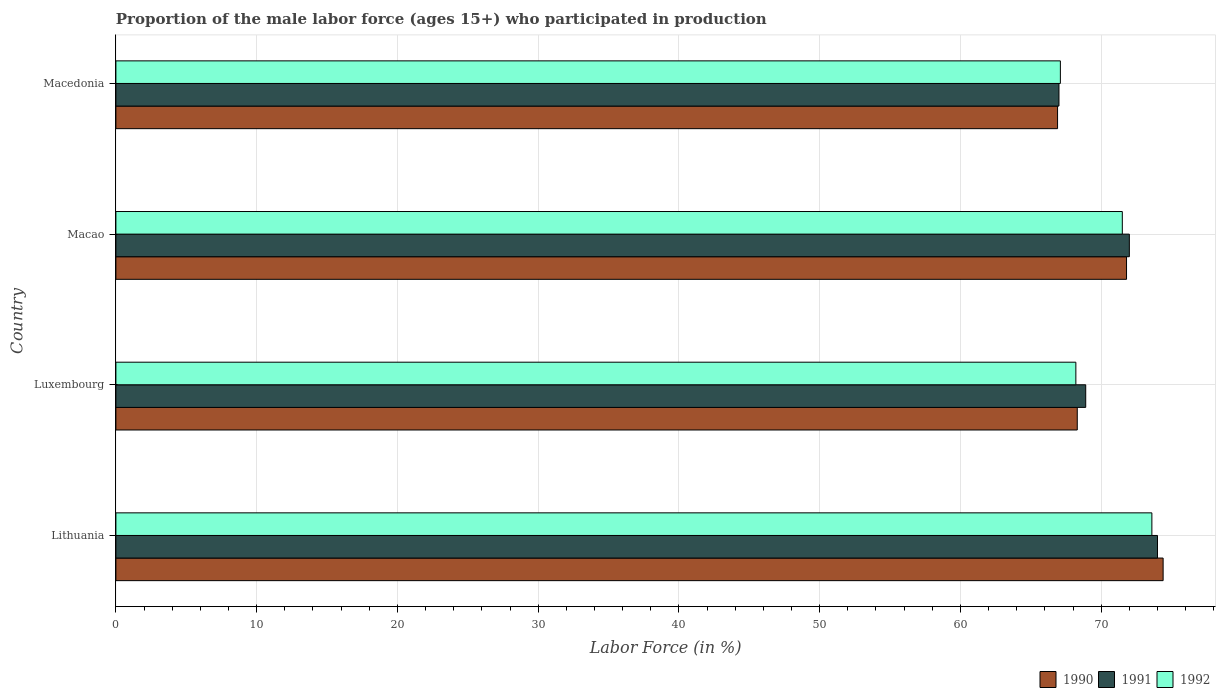How many groups of bars are there?
Your response must be concise. 4. Are the number of bars per tick equal to the number of legend labels?
Provide a short and direct response. Yes. Are the number of bars on each tick of the Y-axis equal?
Your response must be concise. Yes. How many bars are there on the 2nd tick from the bottom?
Your response must be concise. 3. What is the label of the 4th group of bars from the top?
Your answer should be very brief. Lithuania. What is the proportion of the male labor force who participated in production in 1990 in Macao?
Keep it short and to the point. 71.8. Across all countries, what is the maximum proportion of the male labor force who participated in production in 1990?
Your response must be concise. 74.4. Across all countries, what is the minimum proportion of the male labor force who participated in production in 1991?
Give a very brief answer. 67. In which country was the proportion of the male labor force who participated in production in 1991 maximum?
Your answer should be compact. Lithuania. In which country was the proportion of the male labor force who participated in production in 1992 minimum?
Offer a terse response. Macedonia. What is the total proportion of the male labor force who participated in production in 1992 in the graph?
Provide a succinct answer. 280.4. What is the difference between the proportion of the male labor force who participated in production in 1992 in Lithuania and that in Macao?
Keep it short and to the point. 2.1. What is the difference between the proportion of the male labor force who participated in production in 1992 in Macao and the proportion of the male labor force who participated in production in 1991 in Luxembourg?
Ensure brevity in your answer.  2.6. What is the average proportion of the male labor force who participated in production in 1990 per country?
Provide a short and direct response. 70.35. What is the difference between the proportion of the male labor force who participated in production in 1992 and proportion of the male labor force who participated in production in 1991 in Luxembourg?
Your answer should be very brief. -0.7. What is the ratio of the proportion of the male labor force who participated in production in 1991 in Lithuania to that in Luxembourg?
Your answer should be compact. 1.07. Is the difference between the proportion of the male labor force who participated in production in 1992 in Lithuania and Luxembourg greater than the difference between the proportion of the male labor force who participated in production in 1991 in Lithuania and Luxembourg?
Make the answer very short. Yes. What is the difference between the highest and the second highest proportion of the male labor force who participated in production in 1990?
Give a very brief answer. 2.6. Is it the case that in every country, the sum of the proportion of the male labor force who participated in production in 1991 and proportion of the male labor force who participated in production in 1990 is greater than the proportion of the male labor force who participated in production in 1992?
Offer a very short reply. Yes. How many bars are there?
Make the answer very short. 12. Are the values on the major ticks of X-axis written in scientific E-notation?
Ensure brevity in your answer.  No. Does the graph contain any zero values?
Your answer should be compact. No. Does the graph contain grids?
Provide a succinct answer. Yes. What is the title of the graph?
Offer a terse response. Proportion of the male labor force (ages 15+) who participated in production. Does "2013" appear as one of the legend labels in the graph?
Offer a very short reply. No. What is the label or title of the X-axis?
Provide a short and direct response. Labor Force (in %). What is the Labor Force (in %) of 1990 in Lithuania?
Make the answer very short. 74.4. What is the Labor Force (in %) in 1991 in Lithuania?
Keep it short and to the point. 74. What is the Labor Force (in %) of 1992 in Lithuania?
Offer a terse response. 73.6. What is the Labor Force (in %) of 1990 in Luxembourg?
Keep it short and to the point. 68.3. What is the Labor Force (in %) of 1991 in Luxembourg?
Your answer should be compact. 68.9. What is the Labor Force (in %) in 1992 in Luxembourg?
Offer a terse response. 68.2. What is the Labor Force (in %) in 1990 in Macao?
Provide a short and direct response. 71.8. What is the Labor Force (in %) in 1992 in Macao?
Provide a short and direct response. 71.5. What is the Labor Force (in %) of 1990 in Macedonia?
Ensure brevity in your answer.  66.9. What is the Labor Force (in %) in 1991 in Macedonia?
Your response must be concise. 67. What is the Labor Force (in %) in 1992 in Macedonia?
Your response must be concise. 67.1. Across all countries, what is the maximum Labor Force (in %) of 1990?
Offer a terse response. 74.4. Across all countries, what is the maximum Labor Force (in %) of 1992?
Offer a very short reply. 73.6. Across all countries, what is the minimum Labor Force (in %) of 1990?
Provide a short and direct response. 66.9. Across all countries, what is the minimum Labor Force (in %) in 1992?
Offer a terse response. 67.1. What is the total Labor Force (in %) of 1990 in the graph?
Ensure brevity in your answer.  281.4. What is the total Labor Force (in %) of 1991 in the graph?
Offer a terse response. 281.9. What is the total Labor Force (in %) in 1992 in the graph?
Your response must be concise. 280.4. What is the difference between the Labor Force (in %) of 1991 in Lithuania and that in Luxembourg?
Offer a very short reply. 5.1. What is the difference between the Labor Force (in %) in 1990 in Lithuania and that in Macedonia?
Your answer should be compact. 7.5. What is the difference between the Labor Force (in %) of 1990 in Luxembourg and that in Macao?
Keep it short and to the point. -3.5. What is the difference between the Labor Force (in %) of 1990 in Luxembourg and that in Macedonia?
Make the answer very short. 1.4. What is the difference between the Labor Force (in %) in 1992 in Luxembourg and that in Macedonia?
Make the answer very short. 1.1. What is the difference between the Labor Force (in %) in 1991 in Macao and that in Macedonia?
Give a very brief answer. 5. What is the difference between the Labor Force (in %) of 1990 in Lithuania and the Labor Force (in %) of 1991 in Luxembourg?
Provide a succinct answer. 5.5. What is the difference between the Labor Force (in %) in 1991 in Lithuania and the Labor Force (in %) in 1992 in Luxembourg?
Ensure brevity in your answer.  5.8. What is the difference between the Labor Force (in %) in 1990 in Lithuania and the Labor Force (in %) in 1992 in Macao?
Provide a short and direct response. 2.9. What is the difference between the Labor Force (in %) of 1990 in Lithuania and the Labor Force (in %) of 1991 in Macedonia?
Make the answer very short. 7.4. What is the difference between the Labor Force (in %) of 1990 in Luxembourg and the Labor Force (in %) of 1991 in Macao?
Keep it short and to the point. -3.7. What is the difference between the Labor Force (in %) in 1991 in Luxembourg and the Labor Force (in %) in 1992 in Macedonia?
Make the answer very short. 1.8. What is the average Labor Force (in %) of 1990 per country?
Ensure brevity in your answer.  70.35. What is the average Labor Force (in %) of 1991 per country?
Offer a terse response. 70.47. What is the average Labor Force (in %) of 1992 per country?
Keep it short and to the point. 70.1. What is the difference between the Labor Force (in %) of 1990 and Labor Force (in %) of 1991 in Lithuania?
Your answer should be very brief. 0.4. What is the difference between the Labor Force (in %) of 1990 and Labor Force (in %) of 1992 in Lithuania?
Your answer should be compact. 0.8. What is the difference between the Labor Force (in %) of 1991 and Labor Force (in %) of 1992 in Lithuania?
Offer a terse response. 0.4. What is the difference between the Labor Force (in %) of 1990 and Labor Force (in %) of 1992 in Luxembourg?
Offer a terse response. 0.1. What is the difference between the Labor Force (in %) in 1990 and Labor Force (in %) in 1991 in Macao?
Offer a terse response. -0.2. What is the difference between the Labor Force (in %) in 1990 and Labor Force (in %) in 1992 in Macedonia?
Offer a very short reply. -0.2. What is the difference between the Labor Force (in %) of 1991 and Labor Force (in %) of 1992 in Macedonia?
Give a very brief answer. -0.1. What is the ratio of the Labor Force (in %) in 1990 in Lithuania to that in Luxembourg?
Give a very brief answer. 1.09. What is the ratio of the Labor Force (in %) in 1991 in Lithuania to that in Luxembourg?
Keep it short and to the point. 1.07. What is the ratio of the Labor Force (in %) of 1992 in Lithuania to that in Luxembourg?
Keep it short and to the point. 1.08. What is the ratio of the Labor Force (in %) of 1990 in Lithuania to that in Macao?
Offer a terse response. 1.04. What is the ratio of the Labor Force (in %) of 1991 in Lithuania to that in Macao?
Provide a succinct answer. 1.03. What is the ratio of the Labor Force (in %) of 1992 in Lithuania to that in Macao?
Provide a succinct answer. 1.03. What is the ratio of the Labor Force (in %) in 1990 in Lithuania to that in Macedonia?
Your answer should be very brief. 1.11. What is the ratio of the Labor Force (in %) of 1991 in Lithuania to that in Macedonia?
Make the answer very short. 1.1. What is the ratio of the Labor Force (in %) of 1992 in Lithuania to that in Macedonia?
Your answer should be very brief. 1.1. What is the ratio of the Labor Force (in %) of 1990 in Luxembourg to that in Macao?
Offer a very short reply. 0.95. What is the ratio of the Labor Force (in %) in 1991 in Luxembourg to that in Macao?
Your answer should be very brief. 0.96. What is the ratio of the Labor Force (in %) in 1992 in Luxembourg to that in Macao?
Your answer should be very brief. 0.95. What is the ratio of the Labor Force (in %) of 1990 in Luxembourg to that in Macedonia?
Your answer should be very brief. 1.02. What is the ratio of the Labor Force (in %) of 1991 in Luxembourg to that in Macedonia?
Ensure brevity in your answer.  1.03. What is the ratio of the Labor Force (in %) in 1992 in Luxembourg to that in Macedonia?
Offer a very short reply. 1.02. What is the ratio of the Labor Force (in %) of 1990 in Macao to that in Macedonia?
Your answer should be compact. 1.07. What is the ratio of the Labor Force (in %) in 1991 in Macao to that in Macedonia?
Keep it short and to the point. 1.07. What is the ratio of the Labor Force (in %) in 1992 in Macao to that in Macedonia?
Your answer should be compact. 1.07. What is the difference between the highest and the second highest Labor Force (in %) in 1990?
Your response must be concise. 2.6. What is the difference between the highest and the lowest Labor Force (in %) of 1990?
Offer a terse response. 7.5. 